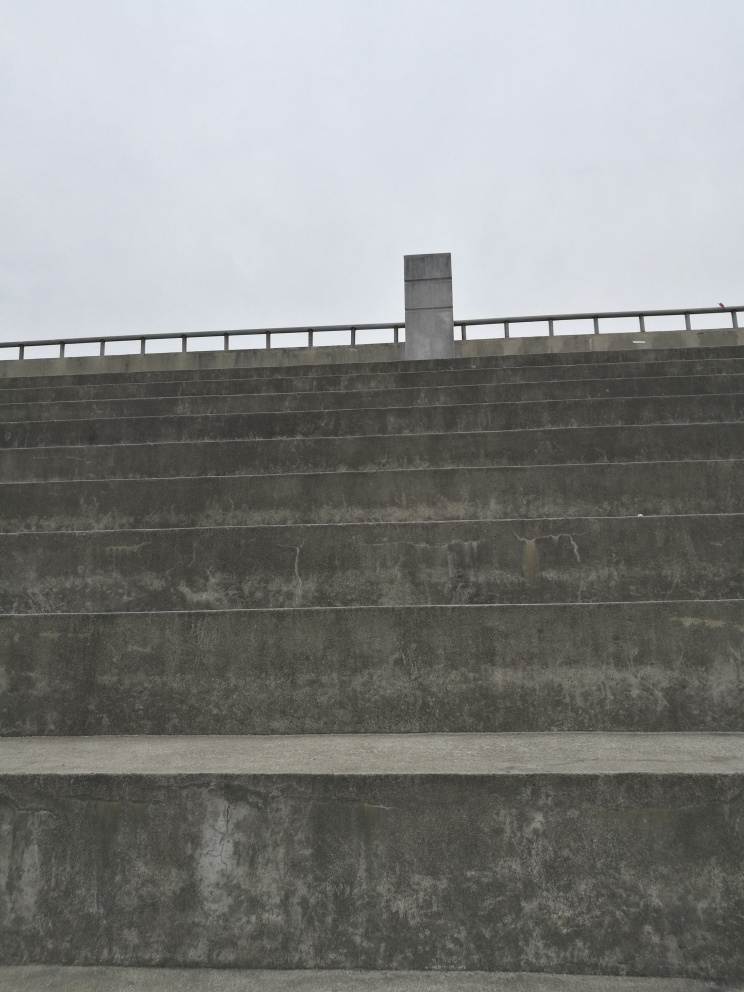Could you speculate on the age and condition of the structure? The structure exhibits signs of weathering, such as staining and slight discoloration, which suggest it is not new and has been exposed to the elements over time. The concrete is intact without major cracks or defects, indicating that despite some age, it has been reasonably well-maintained. 